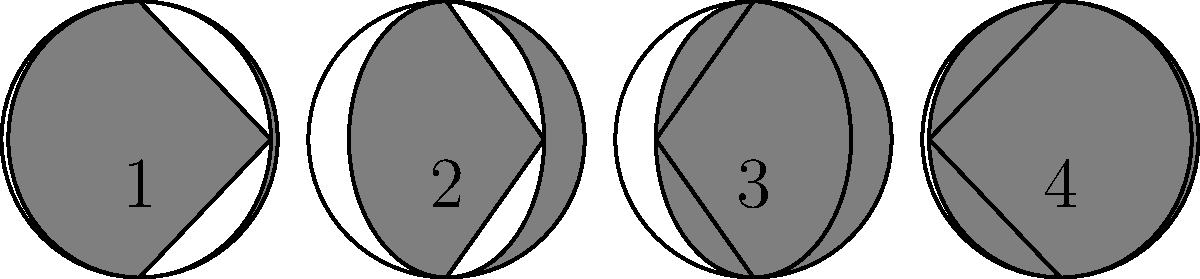As a costume designer, you're working on a ballet production inspired by the lunar cycle. The choreographer wants to incorporate the moon's phases into the dancers' movements and costumes. Which diagram represents the waxing gibbous phase of the moon, often associated with building energy and anticipation in dance? To answer this question, let's break down the moon phases and their representations:

1. The waxing gibbous phase occurs after the first quarter and before the full moon.
2. During this phase, more than half but less than all of the moon's visible surface is illuminated.
3. The illuminated portion is on the right side of the moon as viewed from Earth.
4. This phase is associated with building energy and anticipation, which could be reflected in increasingly elaborate costumes or more dynamic dance movements.

Now, let's analyze each diagram:

1. Diagram 1 shows a thin crescent on the right side, representing a waxing crescent.
2. Diagram 2 shows exactly half of the moon illuminated, representing the first quarter.
3. Diagram 3 shows more than half of the moon illuminated on the right side.
4. Diagram 4 shows almost the entire moon illuminated, with just a small sliver of shadow on the left.

Diagram 3 best represents the waxing gibbous phase, as it shows more than half but less than all of the moon's visible surface illuminated on the right side.

This phase would be ideal for choreographing movements that build in intensity and for designing costumes that gradually reveal more elaborate elements, mirroring the increasing visibility of the moon.
Answer: Diagram 3 